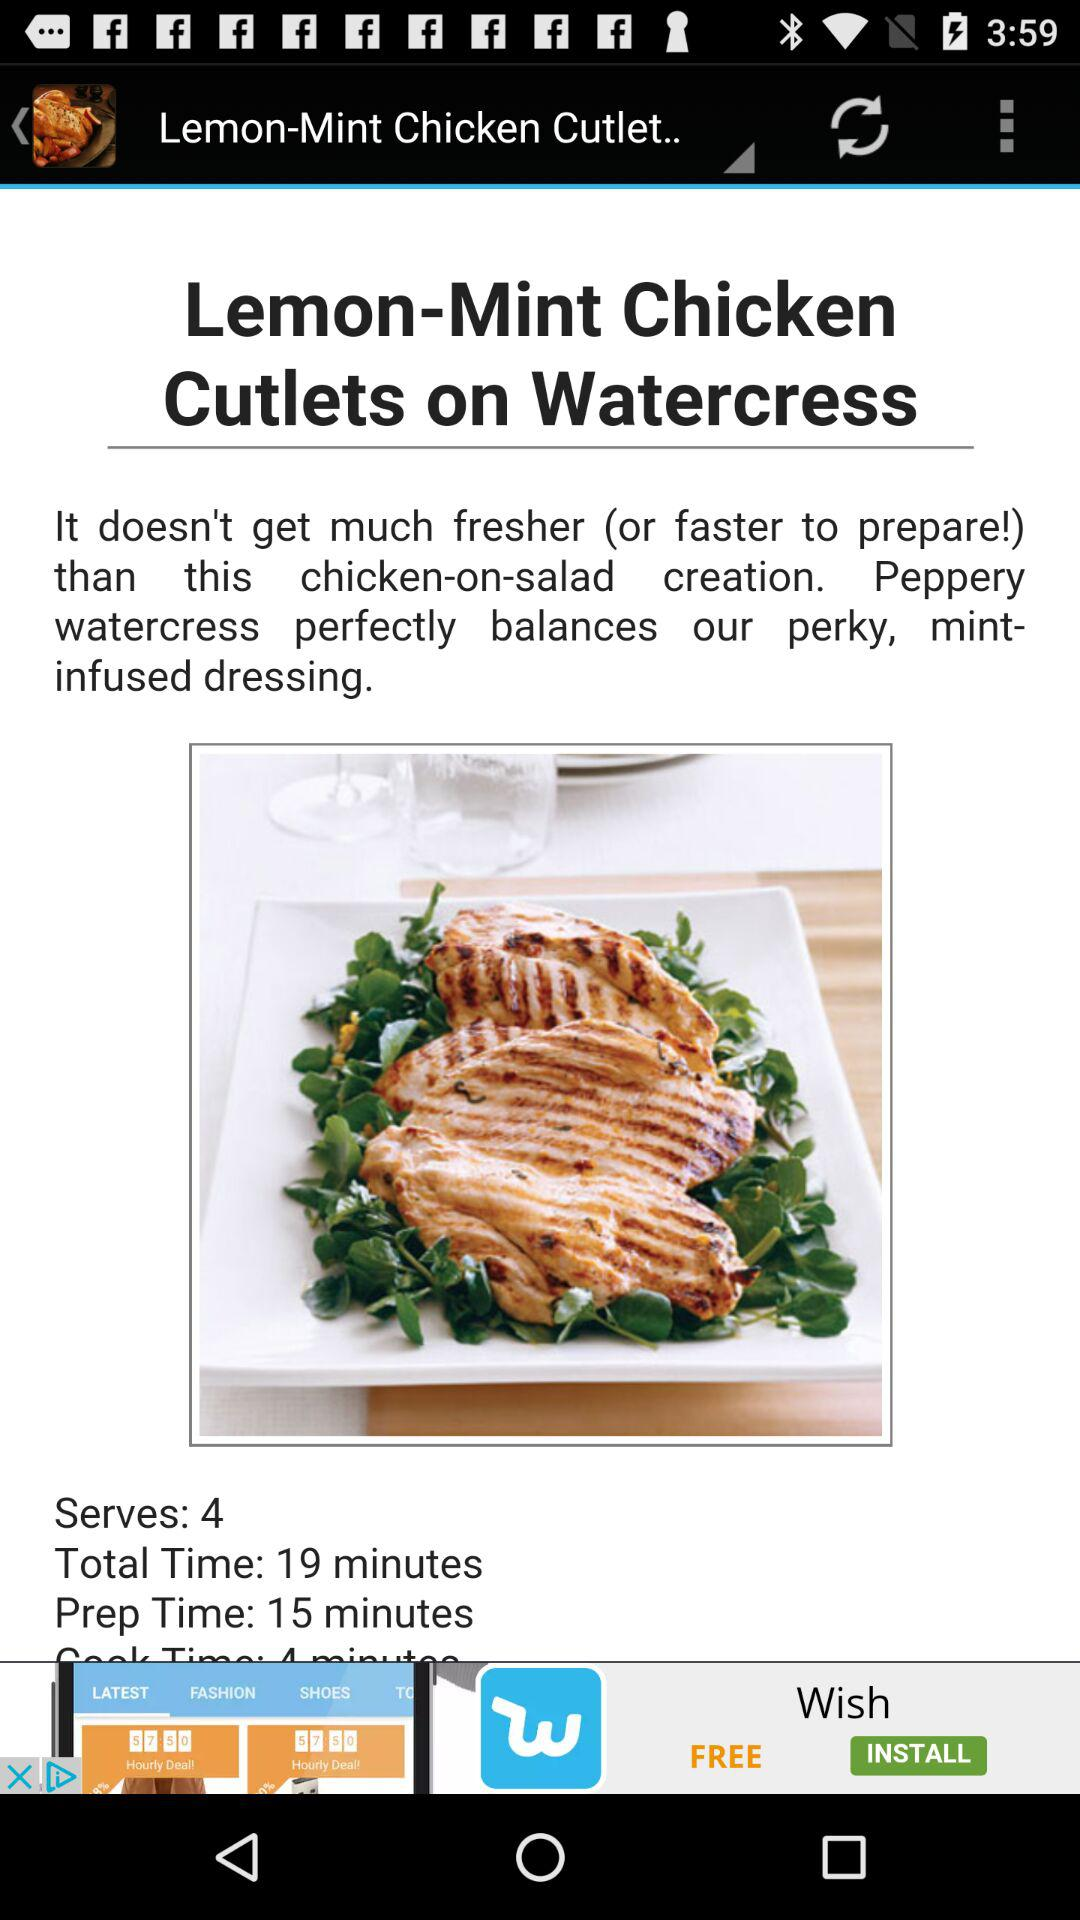How long is the cook time for the dish?
When the provided information is insufficient, respond with <no answer>. <no answer> 